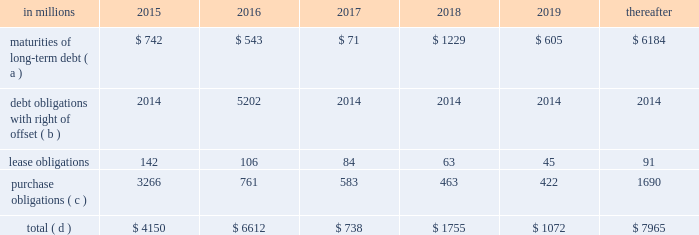On the credit rating of the company and a $ 200 million term loan with an interest rate of libor plus a margin of 175 basis points , both with maturity dates in 2017 .
The proceeds from these borrowings were used , along with available cash , to fund the acquisition of temple- inland .
During 2012 , international paper fully repaid the $ 1.2 billion term loan .
International paper utilizes interest rate swaps to change the mix of fixed and variable rate debt and manage interest expense .
At december 31 , 2012 , international paper had interest rate swaps with a total notional amount of $ 150 million and maturities in 2013 ( see note 14 derivatives and hedging activities on pages 70 through 74 of item 8 .
Financial statements and supplementary data ) .
During 2012 , existing swaps and the amortization of deferred gains on previously terminated swaps decreased the weighted average cost of debt from 6.8% ( 6.8 % ) to an effective rate of 6.6% ( 6.6 % ) .
The inclusion of the offsetting interest income from short- term investments reduced this effective rate to 6.2% ( 6.2 % ) .
Other financing activities during 2012 included the issuance of approximately 1.9 million shares of treasury stock , net of restricted stock withholding , and 1.0 million shares of common stock for various incentive plans , including stock options exercises that generated approximately $ 108 million of cash .
Payment of restricted stock withholding taxes totaled $ 35 million .
Off-balance sheet variable interest entities information concerning off-balance sheet variable interest entities is set forth in note 12 variable interest entities and preferred securities of subsidiaries on pages 67 through 69 of item 8 .
Financial statements and supplementary data for discussion .
Liquidity and capital resources outlook for 2015 capital expenditures and long-term debt international paper expects to be able to meet projected capital expenditures , service existing debt and meet working capital and dividend requirements during 2015 through current cash balances and cash from operations .
Additionally , the company has existing credit facilities totaling $ 2.0 billion of which nothing has been used .
The company was in compliance with all its debt covenants at december 31 , 2014 .
The company 2019s financial covenants require the maintenance of a minimum net worth of $ 9 billion and a total debt-to- capital ratio of less than 60% ( 60 % ) .
Net worth is defined as the sum of common stock , paid-in capital and retained earnings , less treasury stock plus any cumulative goodwill impairment charges .
The calculation also excludes accumulated other comprehensive income/ loss and nonrecourse financial liabilities of special purpose entities .
The total debt-to-capital ratio is defined as total debt divided by the sum of total debt plus net worth .
At december 31 , 2014 , international paper 2019s net worth was $ 14.0 billion , and the total-debt- to-capital ratio was 40% ( 40 % ) .
The company will continue to rely upon debt and capital markets for the majority of any necessary long-term funding not provided by operating cash flows .
Funding decisions will be guided by our capital structure planning objectives .
The primary goals of the company 2019s capital structure planning are to maximize financial flexibility and preserve liquidity while reducing interest expense .
The majority of international paper 2019s debt is accessed through global public capital markets where we have a wide base of investors .
Maintaining an investment grade credit rating is an important element of international paper 2019s financing strategy .
At december 31 , 2014 , the company held long-term credit ratings of bbb ( stable outlook ) and baa2 ( stable outlook ) by s&p and moody 2019s , respectively .
Contractual obligations for future payments under existing debt and lease commitments and purchase obligations at december 31 , 2014 , were as follows: .
( a ) total debt includes scheduled principal payments only .
( b ) represents debt obligations borrowed from non-consolidated variable interest entities for which international paper has , and intends to effect , a legal right to offset these obligations with investments held in the entities .
Accordingly , in its consolidated balance sheet at december 31 , 2014 , international paper has offset approximately $ 5.2 billion of interests in the entities against this $ 5.3 billion of debt obligations held by the entities ( see note 12 variable interest entities and preferred securities of subsidiaries on pages 67 through 69 in item 8 .
Financial statements and supplementary data ) .
( c ) includes $ 2.3 billion relating to fiber supply agreements entered into at the time of the 2006 transformation plan forestland sales and in conjunction with the 2008 acquisition of weyerhaeuser company 2019s containerboard , packaging and recycling business .
( d ) not included in the above table due to the uncertainty as to the amount and timing of the payment are unrecognized tax benefits of approximately $ 119 million .
As discussed in note 12 variable interest entities and preferred securities of subsidiaries on pages 67 through 69 in item 8 .
Financial statements and supplementary data , in connection with the 2006 international paper installment sale of forestlands , we received $ 4.8 billion of installment notes ( or timber notes ) , which we contributed to certain non- consolidated borrower entities .
The installment notes mature in august 2016 ( unless extended ) .
The deferred .
What percentage of contractual obligations for future payments under existing debt and lease commitments and purchase obligations at december 31 , 2014 due in 2016 are purchase obligations? 
Computations: (761 / 6612)
Answer: 0.11509. 